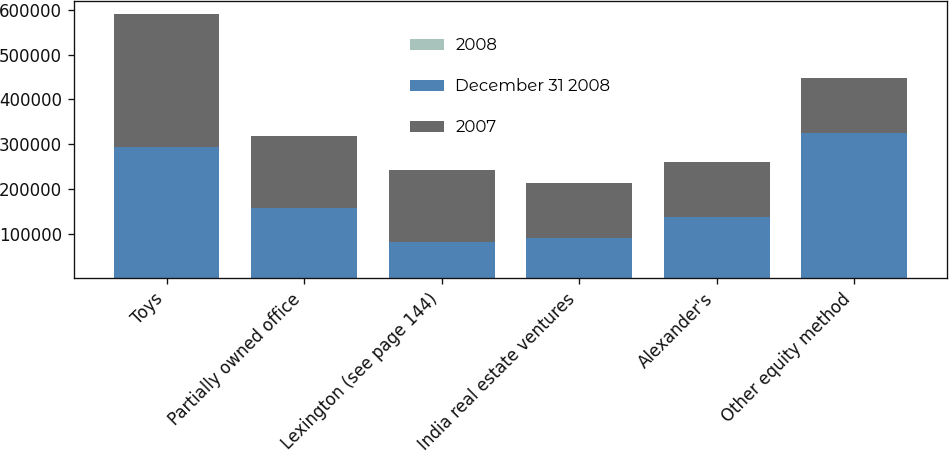<chart> <loc_0><loc_0><loc_500><loc_500><stacked_bar_chart><ecel><fcel>Toys<fcel>Partially owned office<fcel>Lexington (see page 144)<fcel>India real estate ventures<fcel>Alexander's<fcel>Other equity method<nl><fcel>2008<fcel>32.7<fcel>1<fcel>17.2<fcel>450<fcel>32.5<fcel>3<nl><fcel>December 31 2008<fcel>293096<fcel>157468<fcel>80748<fcel>88858<fcel>137305<fcel>325775<nl><fcel>2007<fcel>298089<fcel>161411<fcel>160868<fcel>123997<fcel>122797<fcel>122797<nl></chart> 